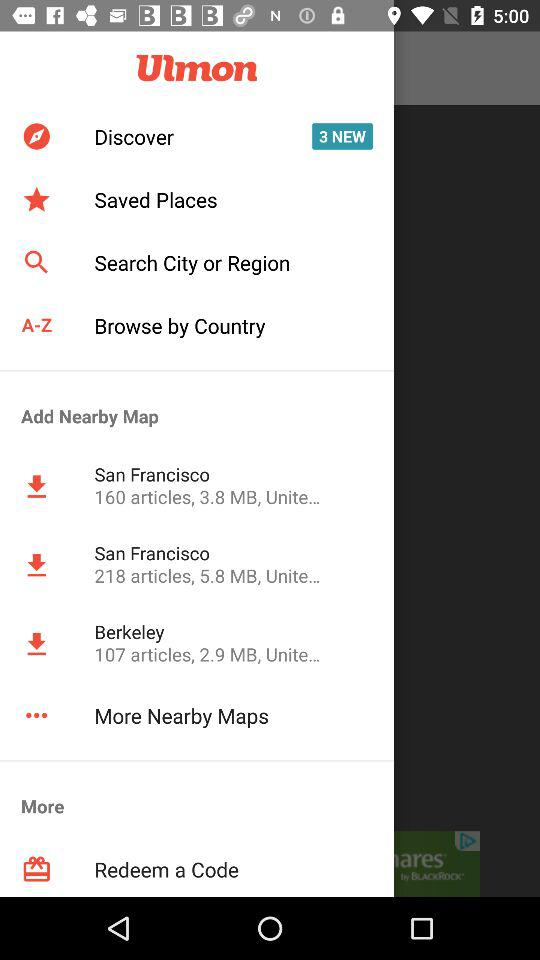How many articles are there in "San Francisco"? There are 160 and 218 articles in "San Francisco". 